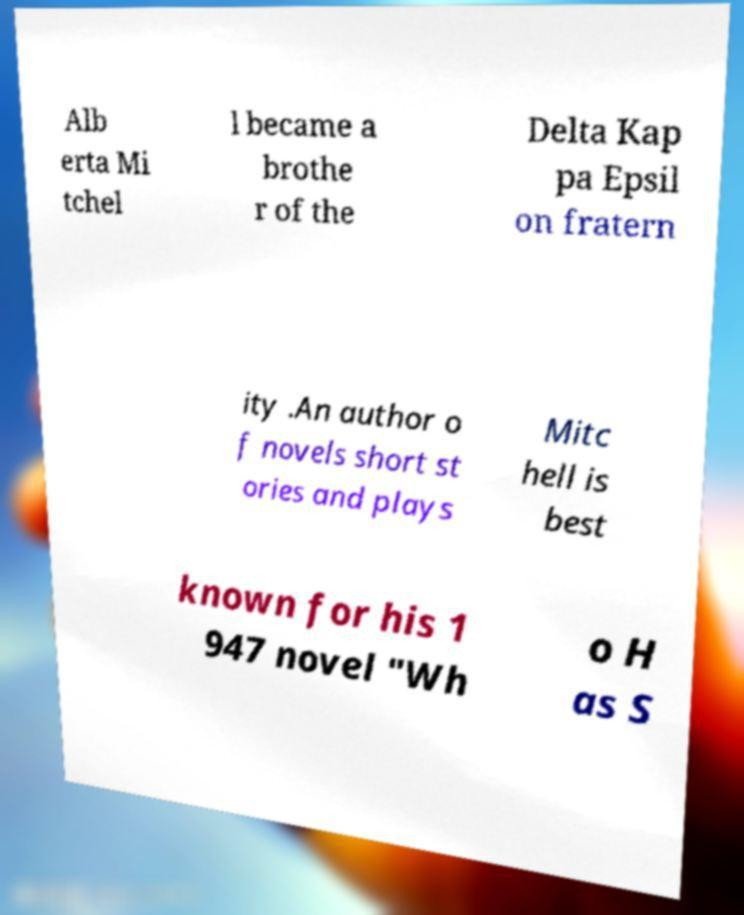I need the written content from this picture converted into text. Can you do that? Alb erta Mi tchel l became a brothe r of the Delta Kap pa Epsil on fratern ity .An author o f novels short st ories and plays Mitc hell is best known for his 1 947 novel "Wh o H as S 